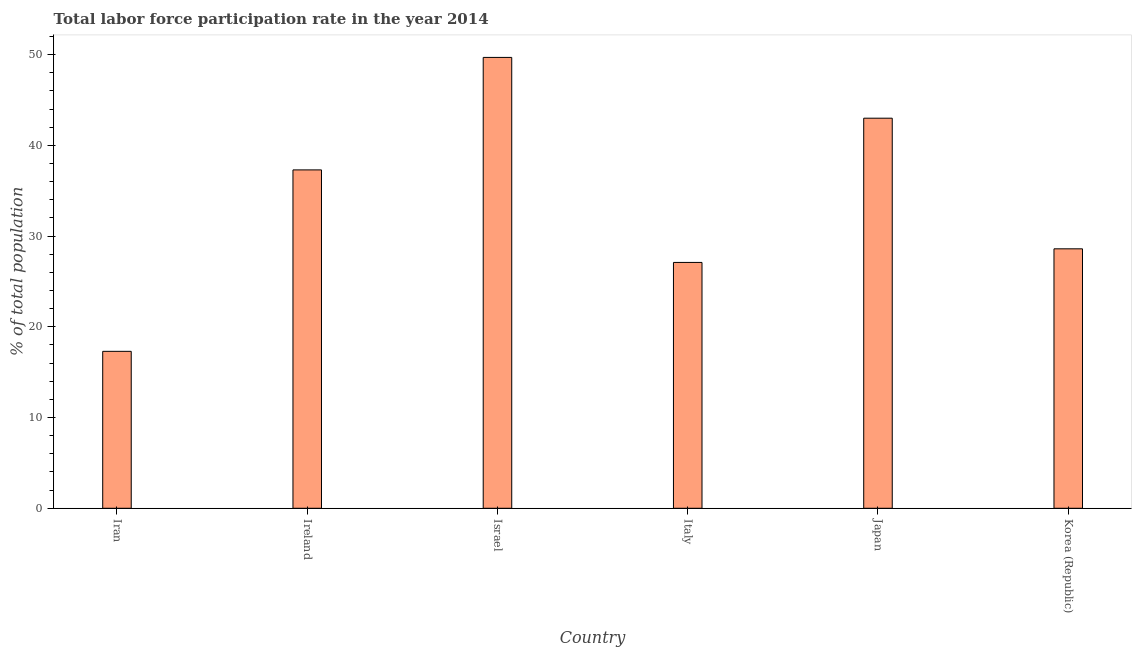Does the graph contain any zero values?
Your response must be concise. No. What is the title of the graph?
Your answer should be compact. Total labor force participation rate in the year 2014. What is the label or title of the Y-axis?
Make the answer very short. % of total population. What is the total labor force participation rate in Iran?
Provide a succinct answer. 17.3. Across all countries, what is the maximum total labor force participation rate?
Offer a terse response. 49.7. Across all countries, what is the minimum total labor force participation rate?
Give a very brief answer. 17.3. In which country was the total labor force participation rate maximum?
Keep it short and to the point. Israel. In which country was the total labor force participation rate minimum?
Your answer should be very brief. Iran. What is the sum of the total labor force participation rate?
Your answer should be very brief. 203. What is the difference between the total labor force participation rate in Ireland and Japan?
Keep it short and to the point. -5.7. What is the average total labor force participation rate per country?
Your answer should be compact. 33.83. What is the median total labor force participation rate?
Ensure brevity in your answer.  32.95. What is the ratio of the total labor force participation rate in Ireland to that in Japan?
Provide a short and direct response. 0.87. Is the sum of the total labor force participation rate in Ireland and Korea (Republic) greater than the maximum total labor force participation rate across all countries?
Provide a succinct answer. Yes. What is the difference between the highest and the lowest total labor force participation rate?
Keep it short and to the point. 32.4. In how many countries, is the total labor force participation rate greater than the average total labor force participation rate taken over all countries?
Ensure brevity in your answer.  3. How many bars are there?
Make the answer very short. 6. Are all the bars in the graph horizontal?
Give a very brief answer. No. What is the difference between two consecutive major ticks on the Y-axis?
Give a very brief answer. 10. Are the values on the major ticks of Y-axis written in scientific E-notation?
Ensure brevity in your answer.  No. What is the % of total population of Iran?
Ensure brevity in your answer.  17.3. What is the % of total population of Ireland?
Ensure brevity in your answer.  37.3. What is the % of total population in Israel?
Keep it short and to the point. 49.7. What is the % of total population of Italy?
Offer a terse response. 27.1. What is the % of total population of Korea (Republic)?
Your response must be concise. 28.6. What is the difference between the % of total population in Iran and Israel?
Your response must be concise. -32.4. What is the difference between the % of total population in Iran and Italy?
Provide a short and direct response. -9.8. What is the difference between the % of total population in Iran and Japan?
Your answer should be compact. -25.7. What is the difference between the % of total population in Iran and Korea (Republic)?
Give a very brief answer. -11.3. What is the difference between the % of total population in Ireland and Korea (Republic)?
Your answer should be very brief. 8.7. What is the difference between the % of total population in Israel and Italy?
Keep it short and to the point. 22.6. What is the difference between the % of total population in Israel and Japan?
Provide a succinct answer. 6.7. What is the difference between the % of total population in Israel and Korea (Republic)?
Offer a very short reply. 21.1. What is the difference between the % of total population in Italy and Japan?
Provide a succinct answer. -15.9. What is the difference between the % of total population in Italy and Korea (Republic)?
Offer a terse response. -1.5. What is the difference between the % of total population in Japan and Korea (Republic)?
Provide a short and direct response. 14.4. What is the ratio of the % of total population in Iran to that in Ireland?
Provide a succinct answer. 0.46. What is the ratio of the % of total population in Iran to that in Israel?
Give a very brief answer. 0.35. What is the ratio of the % of total population in Iran to that in Italy?
Make the answer very short. 0.64. What is the ratio of the % of total population in Iran to that in Japan?
Your response must be concise. 0.4. What is the ratio of the % of total population in Iran to that in Korea (Republic)?
Your answer should be very brief. 0.6. What is the ratio of the % of total population in Ireland to that in Israel?
Your answer should be very brief. 0.75. What is the ratio of the % of total population in Ireland to that in Italy?
Your response must be concise. 1.38. What is the ratio of the % of total population in Ireland to that in Japan?
Your answer should be compact. 0.87. What is the ratio of the % of total population in Ireland to that in Korea (Republic)?
Provide a short and direct response. 1.3. What is the ratio of the % of total population in Israel to that in Italy?
Provide a succinct answer. 1.83. What is the ratio of the % of total population in Israel to that in Japan?
Offer a very short reply. 1.16. What is the ratio of the % of total population in Israel to that in Korea (Republic)?
Offer a very short reply. 1.74. What is the ratio of the % of total population in Italy to that in Japan?
Provide a succinct answer. 0.63. What is the ratio of the % of total population in Italy to that in Korea (Republic)?
Provide a short and direct response. 0.95. What is the ratio of the % of total population in Japan to that in Korea (Republic)?
Give a very brief answer. 1.5. 